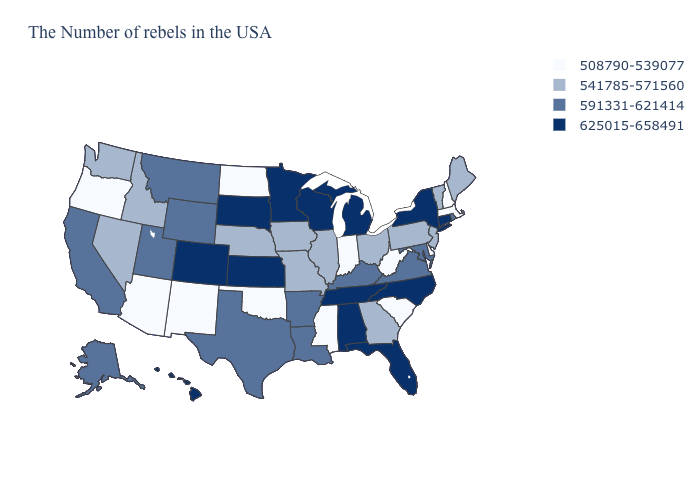What is the value of New Mexico?
Write a very short answer. 508790-539077. What is the lowest value in the USA?
Write a very short answer. 508790-539077. Among the states that border Vermont , does New York have the highest value?
Short answer required. Yes. Does New Mexico have the same value as Oklahoma?
Short answer required. Yes. Name the states that have a value in the range 591331-621414?
Keep it brief. Rhode Island, Maryland, Virginia, Kentucky, Louisiana, Arkansas, Texas, Wyoming, Utah, Montana, California, Alaska. Among the states that border Nebraska , does Missouri have the lowest value?
Quick response, please. Yes. Does Iowa have the same value as Florida?
Keep it brief. No. Name the states that have a value in the range 508790-539077?
Keep it brief. Massachusetts, New Hampshire, Delaware, South Carolina, West Virginia, Indiana, Mississippi, Oklahoma, North Dakota, New Mexico, Arizona, Oregon. What is the highest value in the MidWest ?
Short answer required. 625015-658491. What is the value of Wyoming?
Quick response, please. 591331-621414. What is the highest value in the USA?
Be succinct. 625015-658491. What is the value of Massachusetts?
Answer briefly. 508790-539077. What is the highest value in states that border Maine?
Quick response, please. 508790-539077. Name the states that have a value in the range 591331-621414?
Answer briefly. Rhode Island, Maryland, Virginia, Kentucky, Louisiana, Arkansas, Texas, Wyoming, Utah, Montana, California, Alaska. Does the first symbol in the legend represent the smallest category?
Give a very brief answer. Yes. 